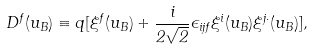Convert formula to latex. <formula><loc_0><loc_0><loc_500><loc_500>D ^ { f } ( u _ { B } ) \equiv q [ \xi ^ { f } ( u _ { B } ) + \frac { i } { 2 \sqrt { 2 } } \epsilon _ { i j f } \xi ^ { i } ( u _ { B } ) \xi ^ { j \cdot } ( u _ { B } ) ] ,</formula> 